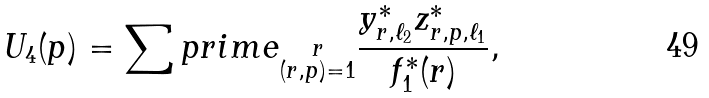<formula> <loc_0><loc_0><loc_500><loc_500>U _ { 4 } ( p ) = \sum p r i m e _ { \substack { r \\ ( r , p ) = 1 } } \frac { y ^ { * } _ { r , \ell _ { 2 } } z ^ { * } _ { r , p , \ell _ { 1 } } } { f _ { 1 } ^ { * } ( r ) } ,</formula> 